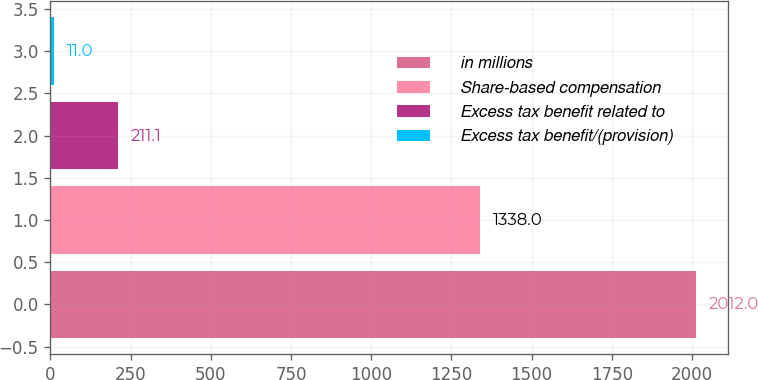<chart> <loc_0><loc_0><loc_500><loc_500><bar_chart><fcel>in millions<fcel>Share-based compensation<fcel>Excess tax benefit related to<fcel>Excess tax benefit/(provision)<nl><fcel>2012<fcel>1338<fcel>211.1<fcel>11<nl></chart> 